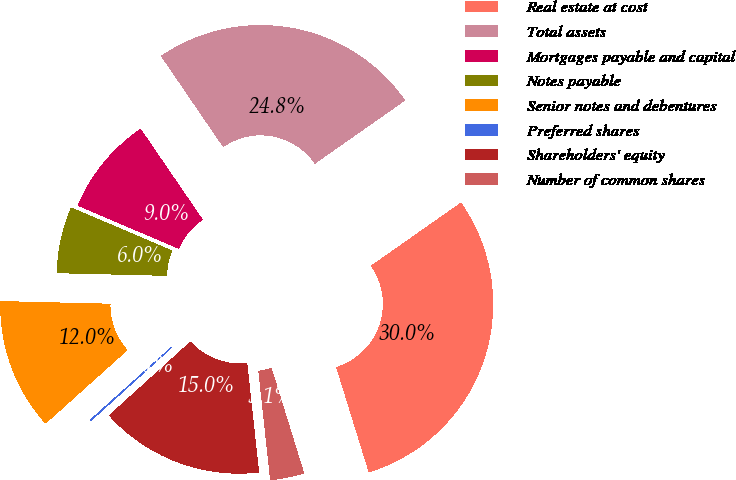Convert chart. <chart><loc_0><loc_0><loc_500><loc_500><pie_chart><fcel>Real estate at cost<fcel>Total assets<fcel>Mortgages payable and capital<fcel>Notes payable<fcel>Senior notes and debentures<fcel>Preferred shares<fcel>Shareholders' equity<fcel>Number of common shares<nl><fcel>29.95%<fcel>24.81%<fcel>9.03%<fcel>6.04%<fcel>12.02%<fcel>0.07%<fcel>15.01%<fcel>3.06%<nl></chart> 